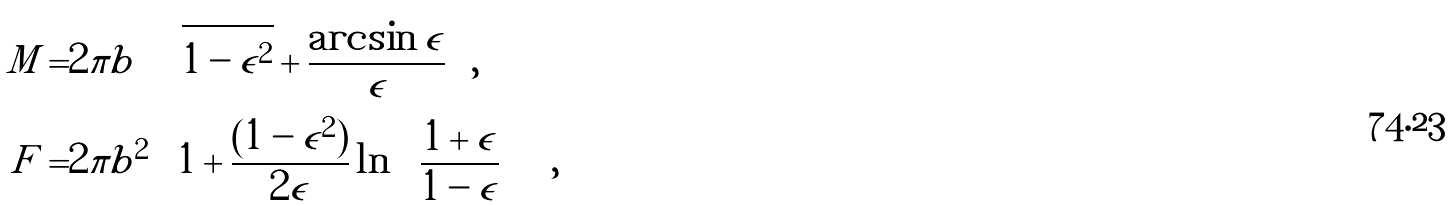Convert formula to latex. <formula><loc_0><loc_0><loc_500><loc_500>M = & 2 \pi b \left ( \sqrt { 1 - \epsilon ^ { 2 } } + \frac { \arcsin { \epsilon } } { \epsilon } \right ) , \\ F = & 2 \pi b ^ { 2 } \left [ 1 + \frac { ( 1 - \epsilon ^ { 2 } ) } { 2 \epsilon } \ln { \left ( \frac { 1 + \epsilon } { 1 - \epsilon } \right ) } \right ] ,</formula> 